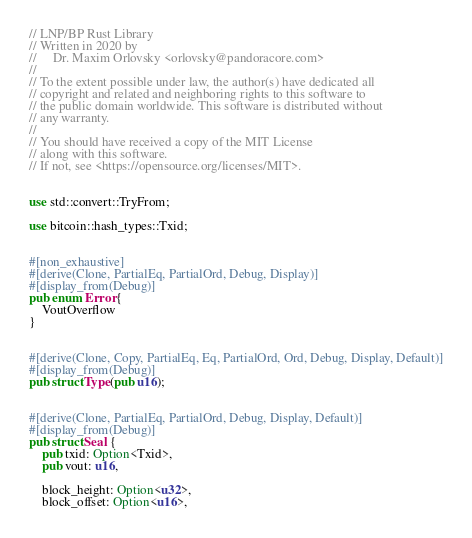<code> <loc_0><loc_0><loc_500><loc_500><_Rust_>// LNP/BP Rust Library
// Written in 2020 by
//     Dr. Maxim Orlovsky <orlovsky@pandoracore.com>
//
// To the extent possible under law, the author(s) have dedicated all
// copyright and related and neighboring rights to this software to
// the public domain worldwide. This software is distributed without
// any warranty.
//
// You should have received a copy of the MIT License
// along with this software.
// If not, see <https://opensource.org/licenses/MIT>.


use std::convert::TryFrom;

use bitcoin::hash_types::Txid;


#[non_exhaustive]
#[derive(Clone, PartialEq, PartialOrd, Debug, Display)]
#[display_from(Debug)]
pub enum Error {
    VoutOverflow
}


#[derive(Clone, Copy, PartialEq, Eq, PartialOrd, Ord, Debug, Display, Default)]
#[display_from(Debug)]
pub struct Type(pub u16);


#[derive(Clone, PartialEq, PartialOrd, Debug, Display, Default)]
#[display_from(Debug)]
pub struct Seal {
    pub txid: Option<Txid>,
    pub vout: u16,

    block_height: Option<u32>,
    block_offset: Option<u16>,</code> 